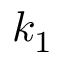<formula> <loc_0><loc_0><loc_500><loc_500>k _ { 1 }</formula> 